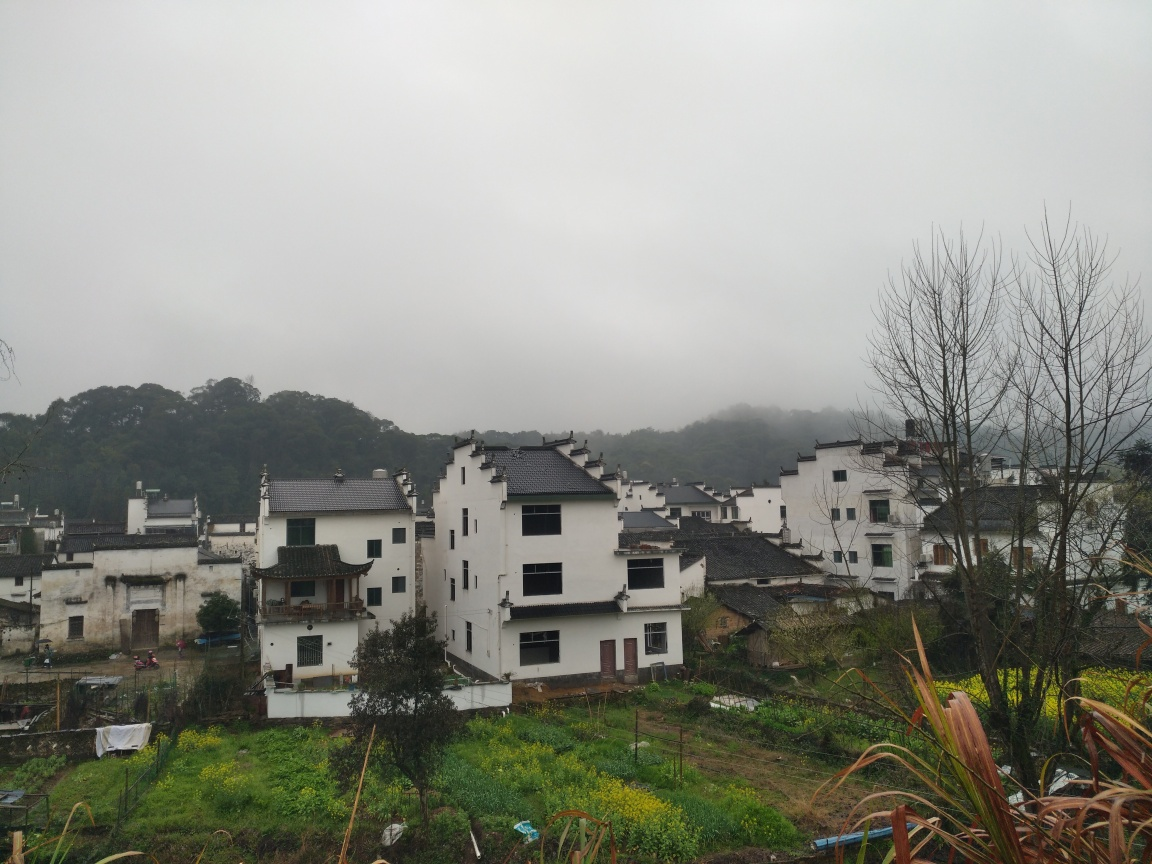What time of year does it look like, and what's the possible location based on the architecture and vegetation? The overcast skies and the absence of leaves on several trees suggest it could be late fall or early winter. The architecture, featuring white walls and black tiles, resembles the traditional style found in some rural regions of East Asia, possibly China. The presence of lush green fields implies a region with a wet or temperate climate. 